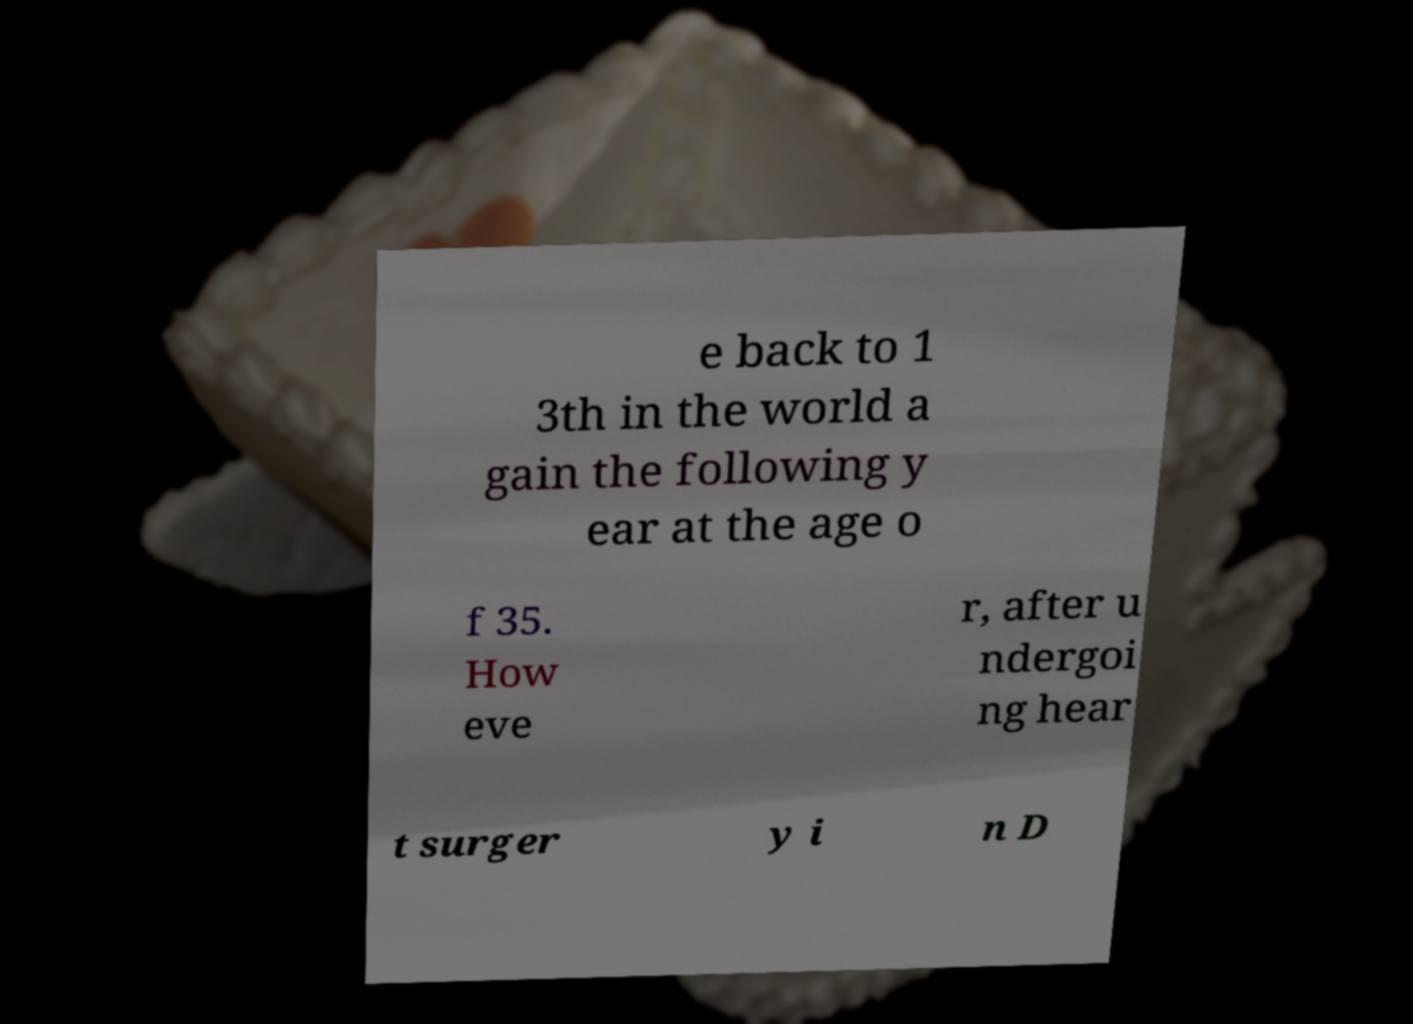Could you assist in decoding the text presented in this image and type it out clearly? e back to 1 3th in the world a gain the following y ear at the age o f 35. How eve r, after u ndergoi ng hear t surger y i n D 